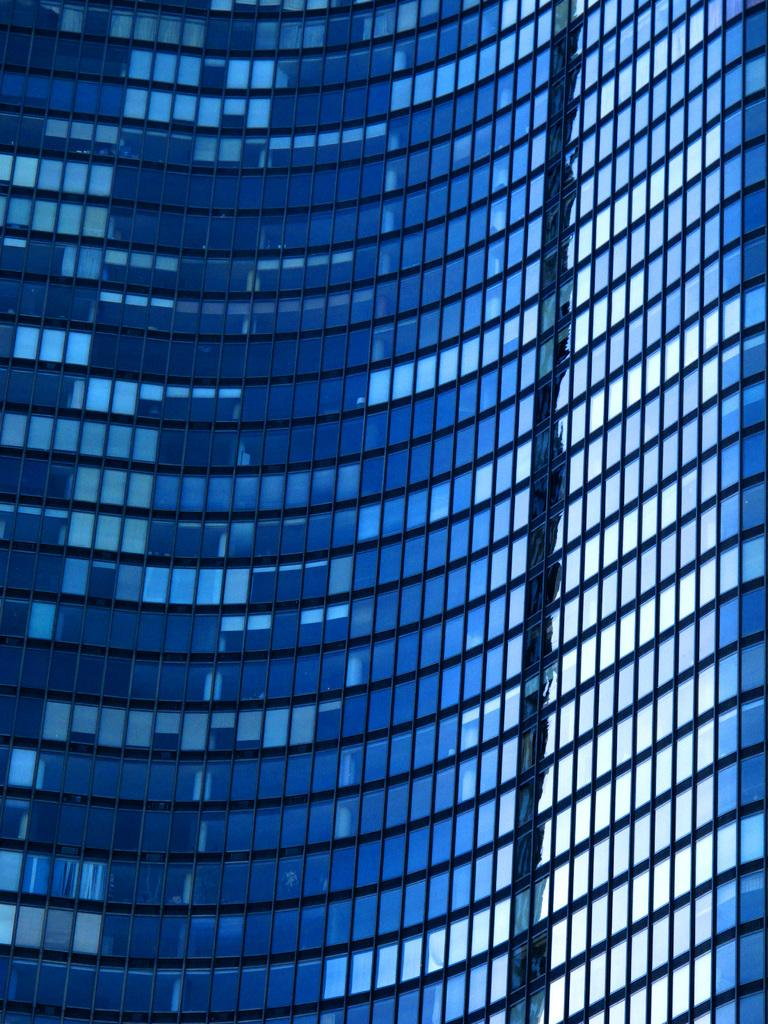What type of structure is present in the image? There is a building in the image. What feature can be seen on the building? The building has glass doors. How does the cub feel about the disgusting ocean in the image? There is no cub or ocean present in the image; it only features a building with glass doors. 